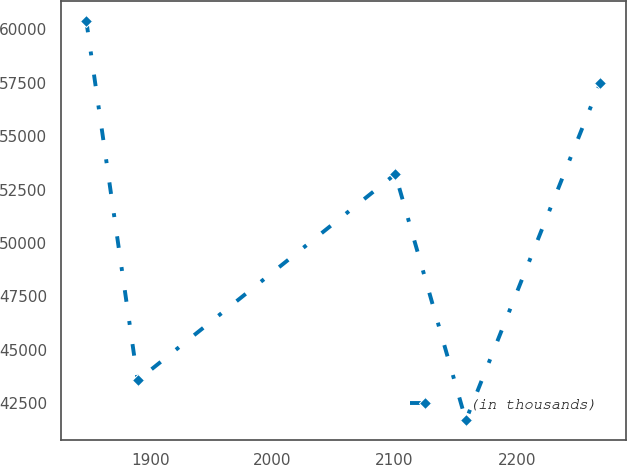Convert chart to OTSL. <chart><loc_0><loc_0><loc_500><loc_500><line_chart><ecel><fcel>(in thousands)<nl><fcel>1847.72<fcel>60399.5<nl><fcel>1889.78<fcel>43576.2<nl><fcel>2100.63<fcel>53222.3<nl><fcel>2158.35<fcel>41707<nl><fcel>2268.29<fcel>57476.4<nl></chart> 